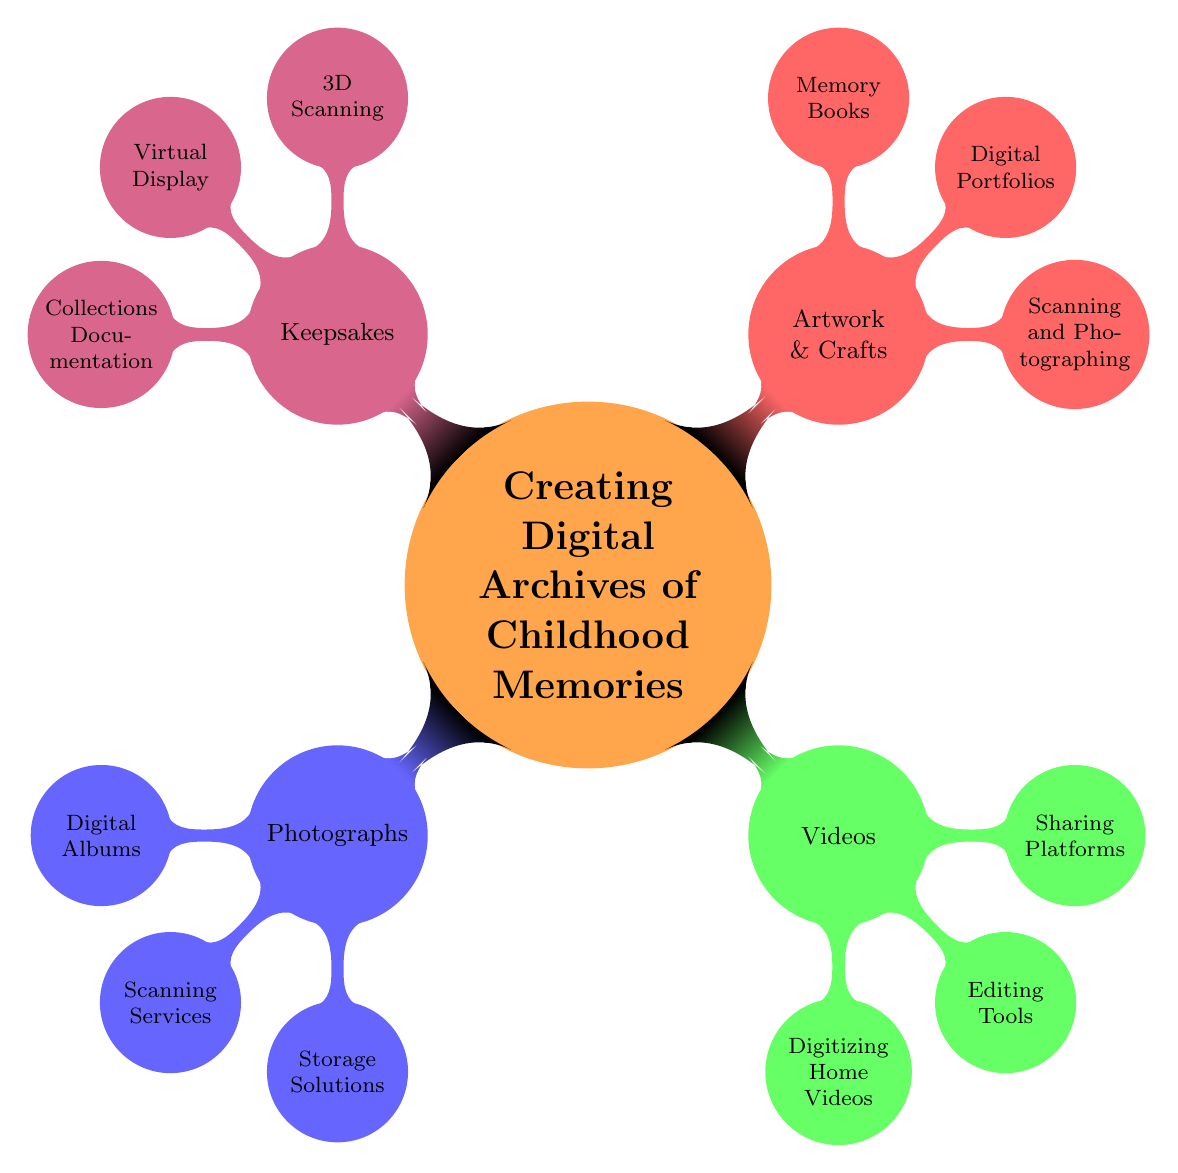What are the main categories of childhood memories in the mind map? The mind map features four main categories: Photographs, Videos, Artwork & Crafts, and Keepsakes. Each category branches out into more specific aspects of creating digital archives.
Answer: Photographs, Videos, Artwork & Crafts, Keepsakes How many subcategories does the 'Videos' category contain? The 'Videos' category has three subcategories: Digitizing Home Videos, Editing Tools, and Sharing Platforms. This count comes directly from the branching under the 'Videos' node.
Answer: 3 What is one type of storage solution listed under the 'Photographs' category? The 'Photographs' category includes various options, one of which is Cloud Storage. This information is found in the third-level node directly under 'Storage Solutions.'
Answer: Cloud Storage Which category includes 'Audio Narratives (Voice Memos)'? 'Audio Narratives (Voice Memos)' is listed under the 'Keepsakes' category as part of Collections Documentation. By navigating through the branches, we can locate it in the specific context of keepsakes.
Answer: Keepsakes What tool is suggested for editing videos? The mind map presents Adobe Premiere as one of the tools for editing videos, found under the second-level node of the 'Editing Tools' subcategory.
Answer: Adobe Premiere How do 'Digital Albums' relate to the 'Photographs' category? 'Digital Albums' is a subcategory directly under the 'Photographs' main category, indicating that they are a method for organizing and showcasing digital images related to childhood memories.
Answer: Subcategory What is a digital portfolio option mentioned for Artwork & Crafts? Google Drive Folders is mentioned as a digital portfolio option for Artwork & Crafts, indicating a way to organize and display digital versions of a child's art and crafts.
Answer: Google Drive Folders Which scanning method is associated with keepsakes in the mind map? The keepsakes category includes '3D Scanning' as a method associated with preserving these items. This is a first-level subcategory directly under Keepsakes.
Answer: 3D Scanning How is 'Shutterfly' related to Artwork & Crafts? 'Shutterfly' is listed as one of the options for creating Memory Books under the Artwork & Crafts category, indicating its use in preserving memories through printed formats.
Answer: Memory Books 